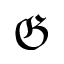Convert formula to latex. <formula><loc_0><loc_0><loc_500><loc_500>\mathfrak { G }</formula> 